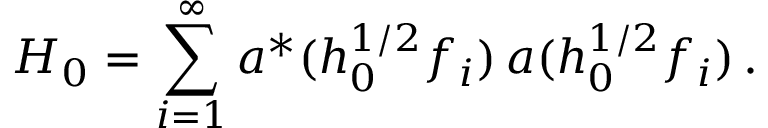<formula> <loc_0><loc_0><loc_500><loc_500>H _ { 0 } = \sum _ { i = 1 } ^ { \infty } a ^ { * } ( h _ { 0 } ^ { 1 / 2 } f _ { i } ) \, a ( h _ { 0 } ^ { 1 / 2 } f _ { i } ) \, .</formula> 